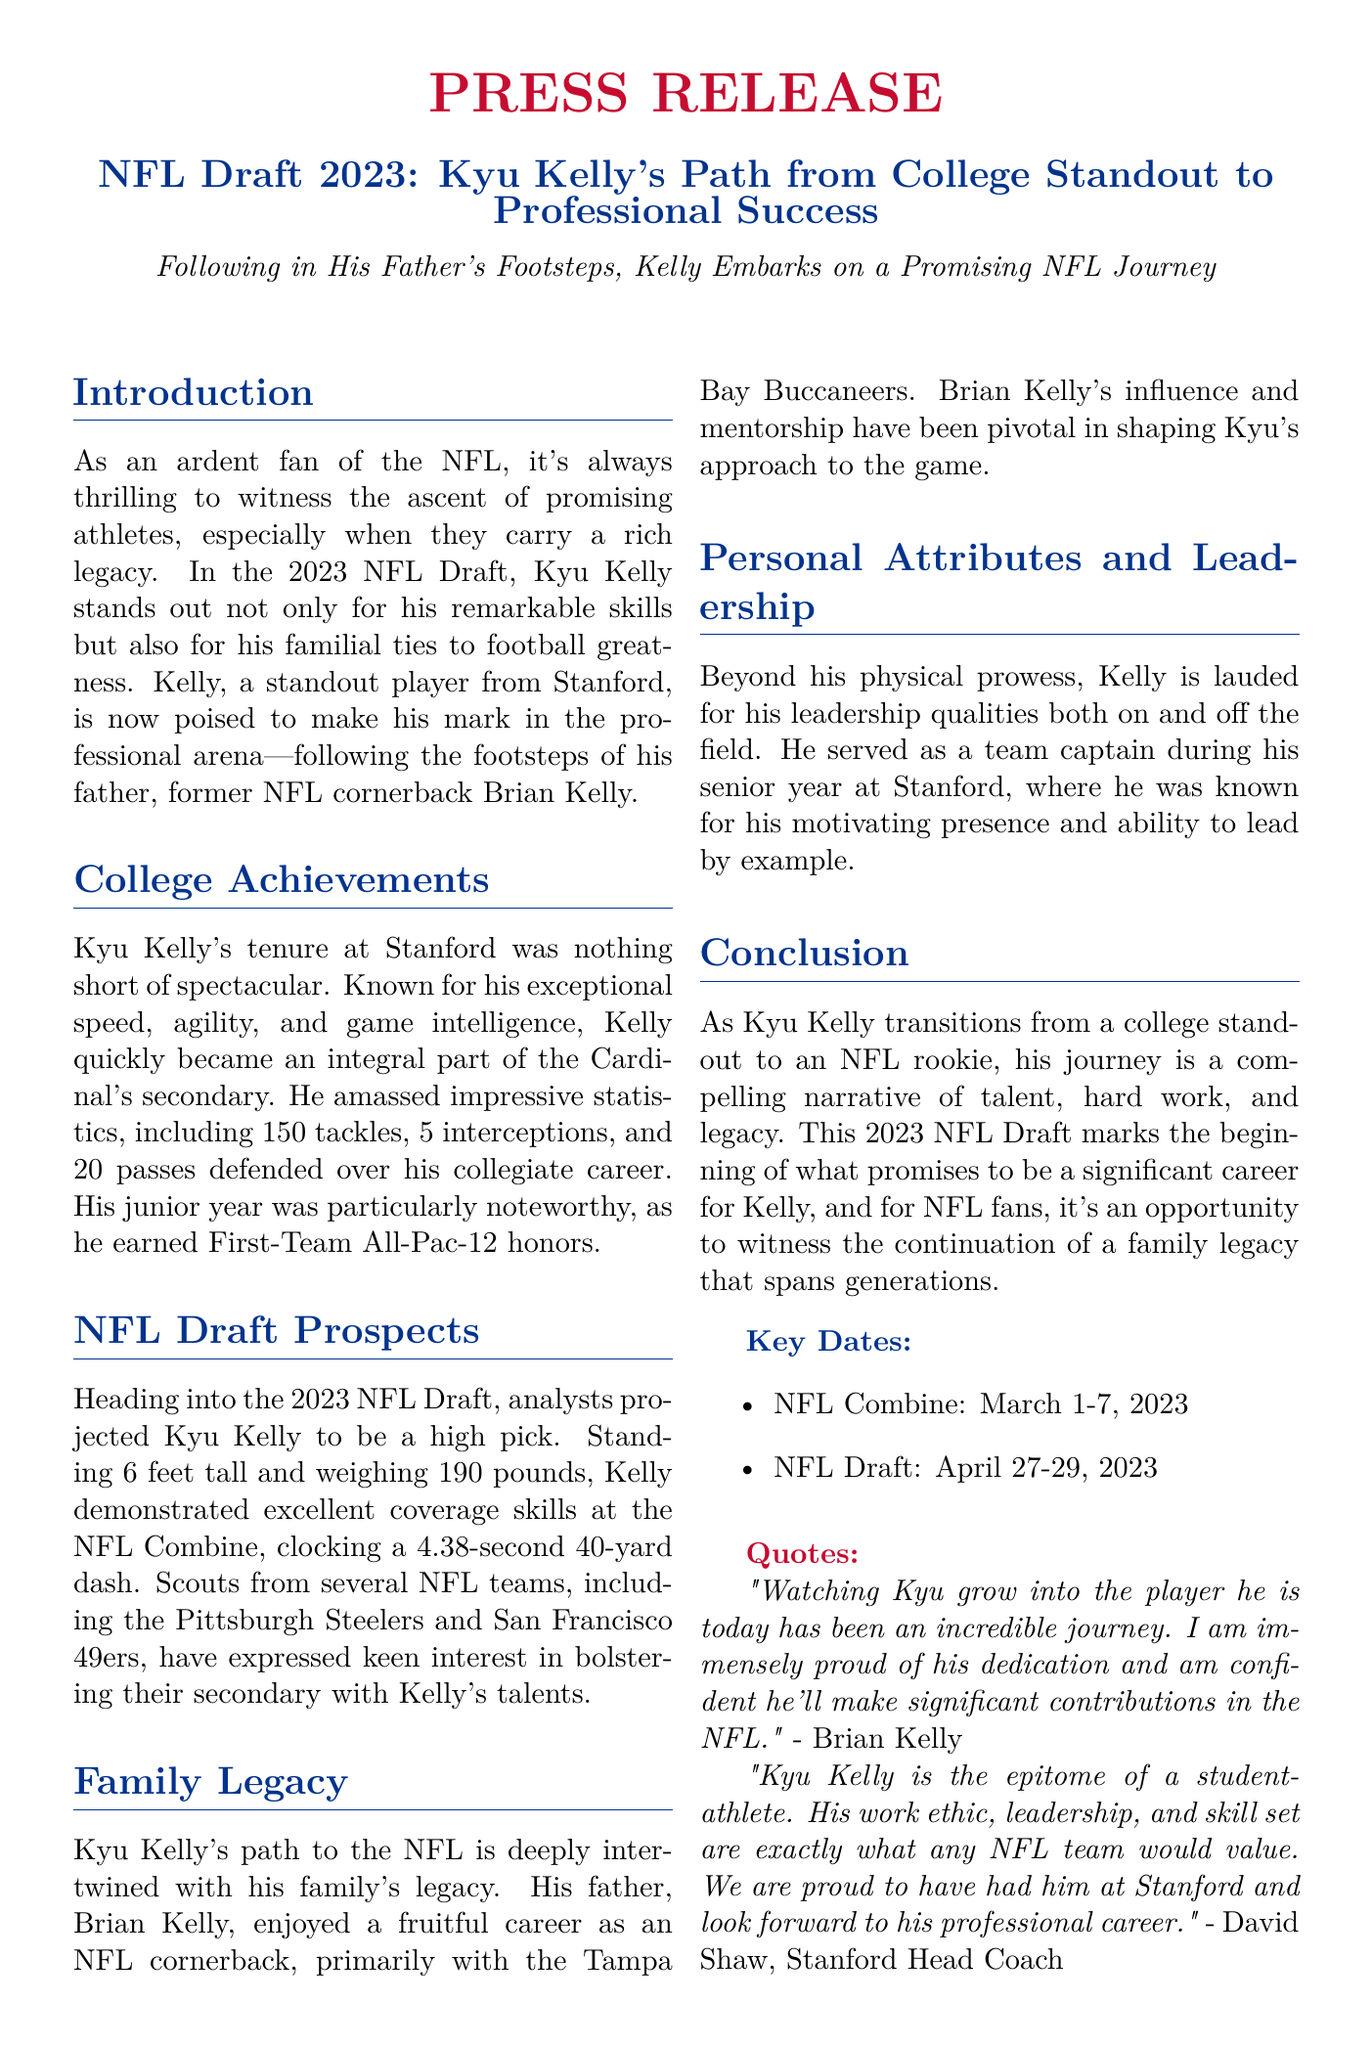What college did Kyu Kelly attend? The document states that Kyu Kelly is a standout player from Stanford.
Answer: Stanford How many interceptions did Kyu Kelly have in college? The text provides specific statistics that include 5 interceptions during Kyu's collegiate career.
Answer: 5 What year was Kyu Kelly's junior year when he earned First-Team All-Pac-12 honors? The document mentions his junior year as being particularly noteworthy, but does not specify the year; however, since he played in college leading up to the 2023 NFL Draft, it can be inferred as 2022.
Answer: 2022 What is Kyu Kelly's height and weight? The passage lists Kyu Kelly's height as 6 feet and weight as 190 pounds.
Answer: 6 feet, 190 pounds Which NFL teams expressed interest in Kyu Kelly? The document states that scouts from the Pittsburgh Steelers and San Francisco 49ers have shown keen interest in Kyu's talents.
Answer: Pittsburgh Steelers, San Francisco 49ers Who is Kyu Kelly's father? The text identifies Kyu's father as Brian Kelly, a former NFL cornerback.
Answer: Brian Kelly What is a key personal attribute of Kyu Kelly mentioned in the document? The press release highlights Kyu Kelly's leadership qualities both on and off the field as a key personal attribute.
Answer: Leadership When did the NFL Draft take place in 2023? The document specifies the dates for the NFL Draft as April 27-29, 2023.
Answer: April 27-29, 2023 What did Brian Kelly say about Kyu's journey? The quote from Brian Kelly expresses pride in Kyu's dedication and confidence in his contributions in the NFL.
Answer: "I am immensely proud of his dedication..." 